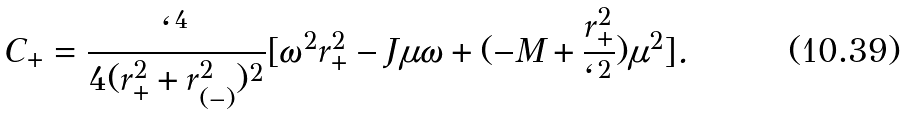Convert formula to latex. <formula><loc_0><loc_0><loc_500><loc_500>C _ { + } = \frac { \ell ^ { 4 } } { 4 ( r _ { + } ^ { 2 } + r _ { ( - ) } ^ { 2 } ) ^ { 2 } } [ \omega ^ { 2 } r _ { + } ^ { 2 } - J \mu \omega + ( - M + \frac { r _ { + } ^ { 2 } } { \ell ^ { 2 } } ) \mu ^ { 2 } ] .</formula> 